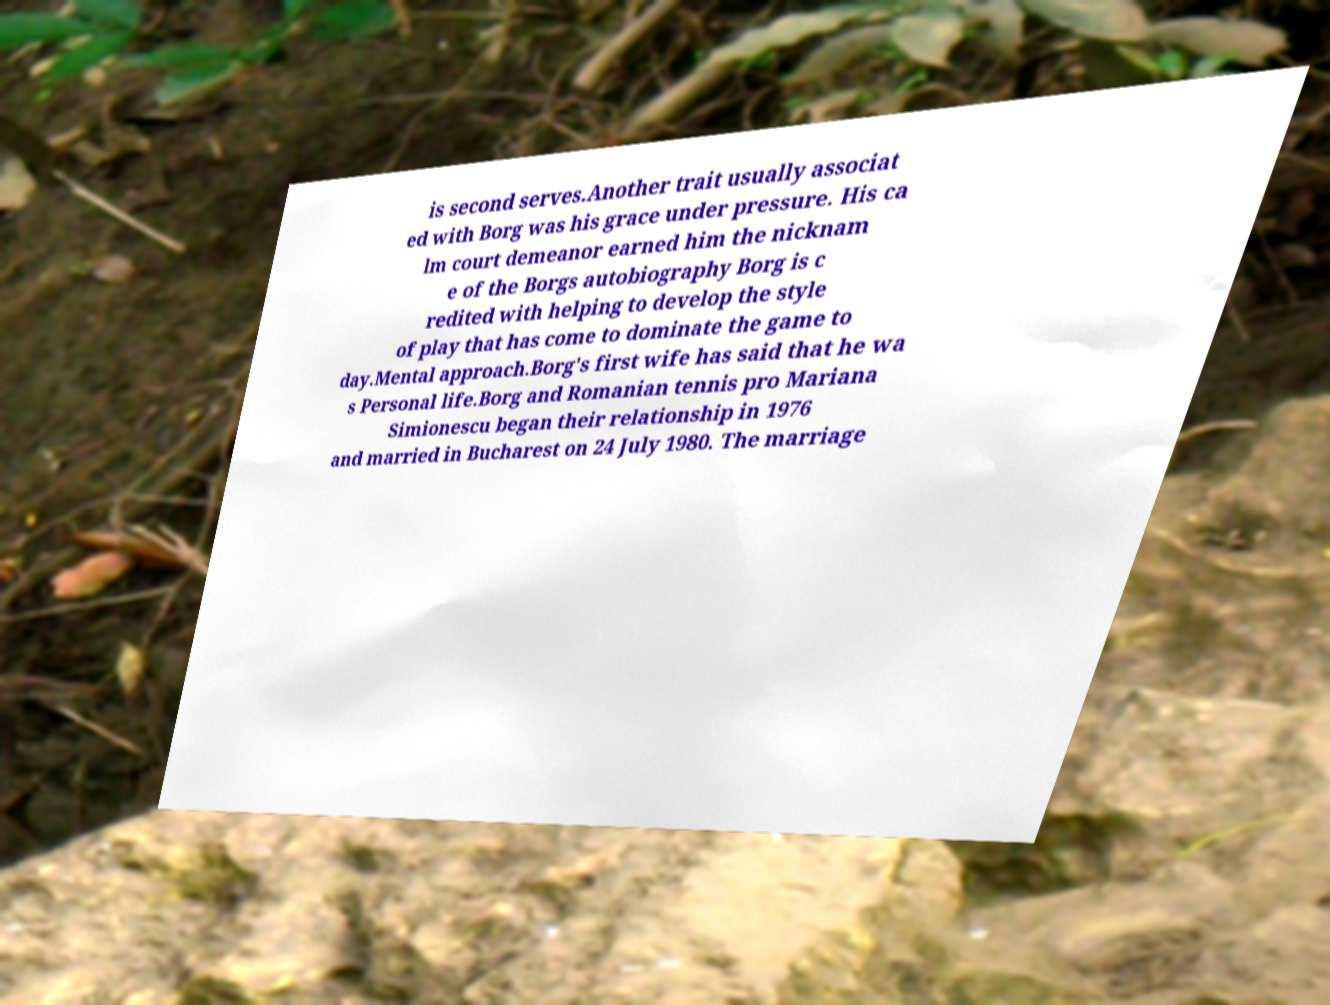Can you accurately transcribe the text from the provided image for me? is second serves.Another trait usually associat ed with Borg was his grace under pressure. His ca lm court demeanor earned him the nicknam e of the Borgs autobiography Borg is c redited with helping to develop the style of play that has come to dominate the game to day.Mental approach.Borg's first wife has said that he wa s Personal life.Borg and Romanian tennis pro Mariana Simionescu began their relationship in 1976 and married in Bucharest on 24 July 1980. The marriage 